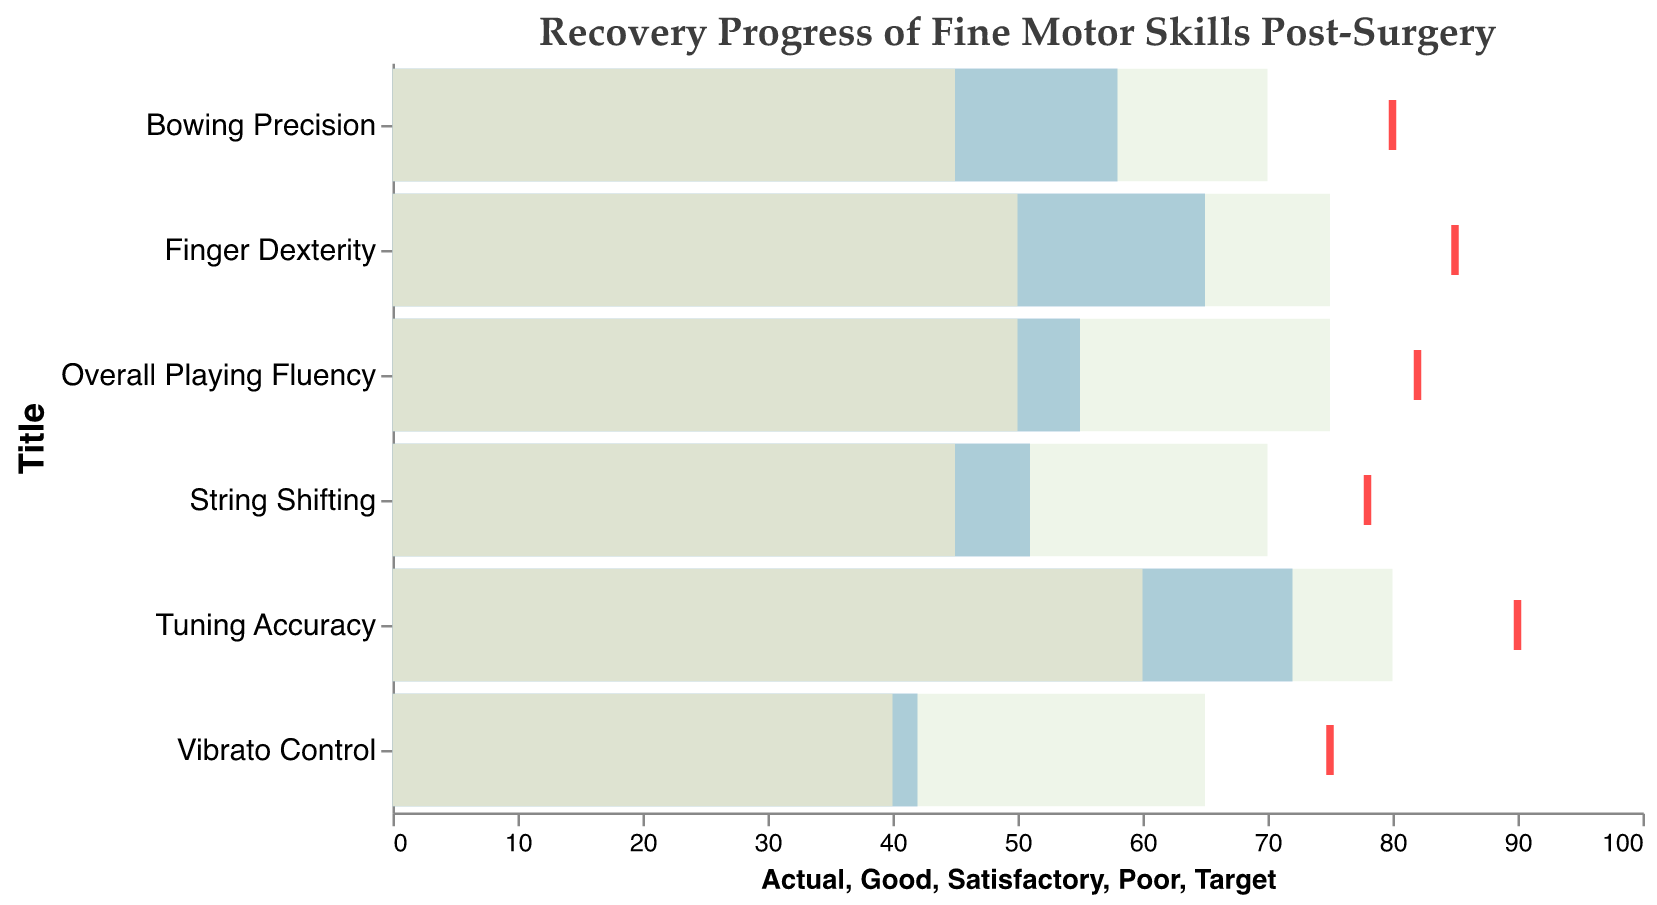What is the title of the chart? The title of the chart is written at the top and reads "Recovery Progress of Fine Motor Skills Post-Surgery."
Answer: Recovery Progress of Fine Motor Skills Post-Surgery What is the actual score for Finger Dexterity? The bar labeled "Finger Dexterity" has a length that corresponds to a value on the x-axis, which is 65.
Answer: 65 Which skill has the highest target score? By looking at the red tick marks indicating the target scores, Tuning Accuracy has the highest target score at 90.
Answer: Tuning Accuracy Which skill is closest to its target score? By comparing the lengths of the blue bars (actual scores) and the positions of the red tick marks (target scores), Tuning Accuracy (actual: 72, target: 90) is closest as the difference is the smallest, 18.
Answer: Tuning Accuracy How many skills have their actual score in the satisfactory range? The satisfactory range is indicated by the light yellow bars. Finger Dexterity, Bowing Precision, String Shifting, and Overall Playing Fluency have their actual scores in this range.
Answer: 4 What colors are used to represent different ranges in the chart? The chart uses light red for 'Poor,' light yellow for 'Satisfactory,' light green for 'Good,' and blue for actual scores.
Answer: Light red, Light yellow, Light green, Blue Among the skills listed, which one has the poorest recovery? The skill with the lowest actual score (blue bar) is Vibrato Control, with a score of 42.
Answer: Vibrato Control What is the range for "Good" performance in Overall Playing Fluency? The green bar corresponding to "Overall Playing Fluency" extends from 0 to 75 on the x-axis.
Answer: 0 to 75 Which skill has the widest gap between its actual score and satisfactory threshold? Comparing the differences between actual scores (blue bars) and satisfactory thresholds (end of light yellow bars), Bowing Precision has the widest gap (58 actual - 45 satisfactory = 13).
Answer: Bowing Precision 